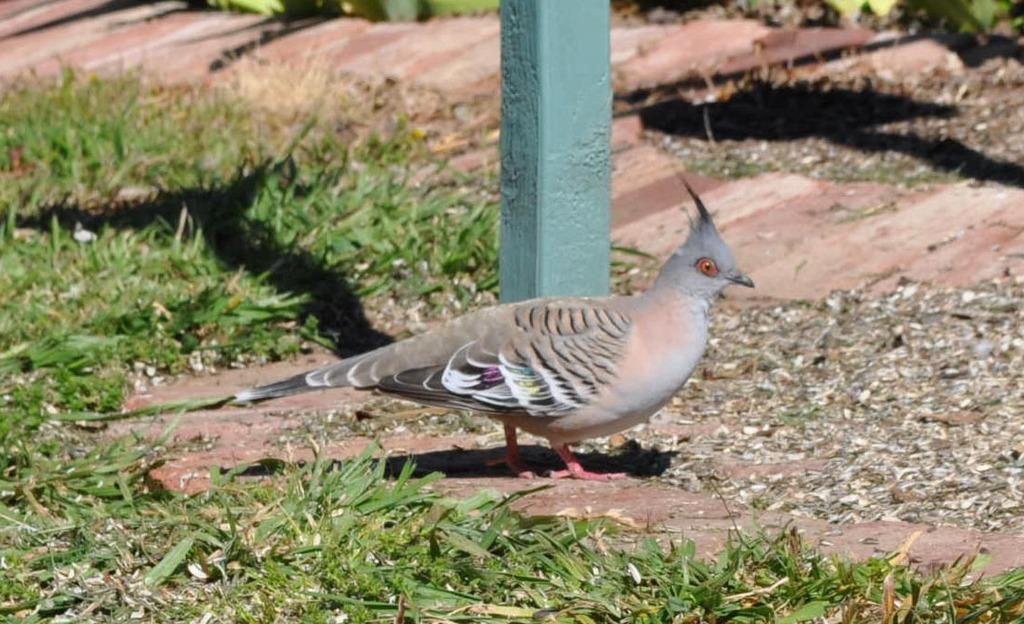What type of animal can be seen in the image? There is a bird in the image. What is the tall, vertical object in the image? There is a pole in the image. What is the surface that the bird and pole are standing on? The ground is visible in the image. What can be found on the ground in the image? There are objects on the ground. What type of vegetation is present in the image? There is grass in the image. Can you see any boats in the image? There are no boats present in the image. What type of sticks are being used by the bird to build a nest in the image? There is no nest or sticks visible in the image; it only features a bird, pole, ground, objects on the ground, and grass. 